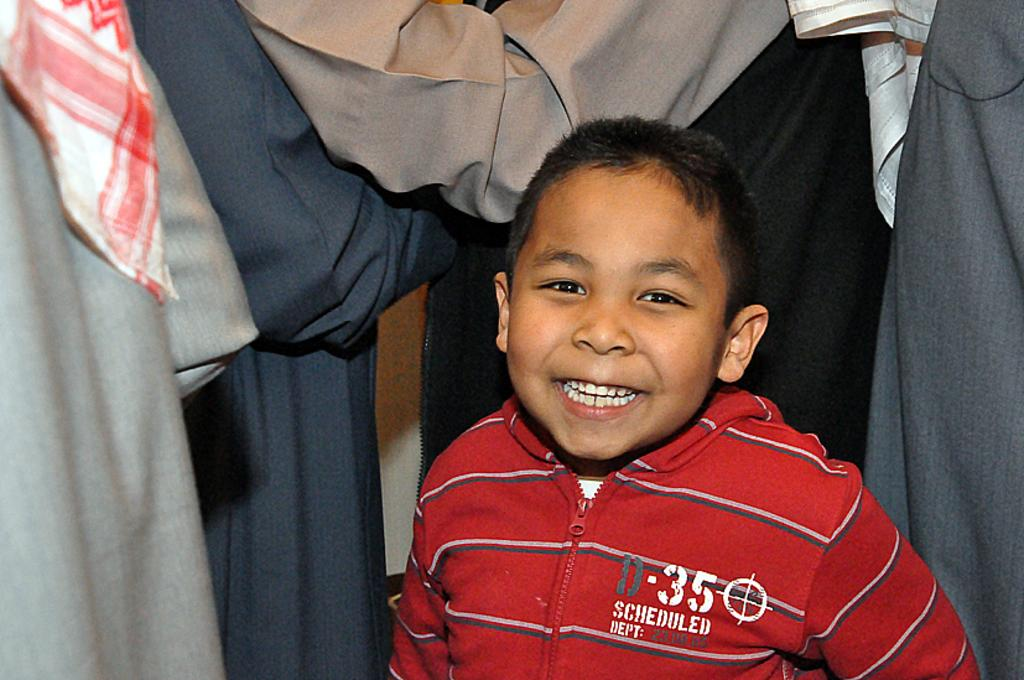What is the main subject of the image? The main subject of the image is a boy standing. Are there any other people in the image? Yes, there is a group of people around the boy. What type of fruit is the boy holding in the image? There is no fruit present in the image; the boy is not holding any fruit. 